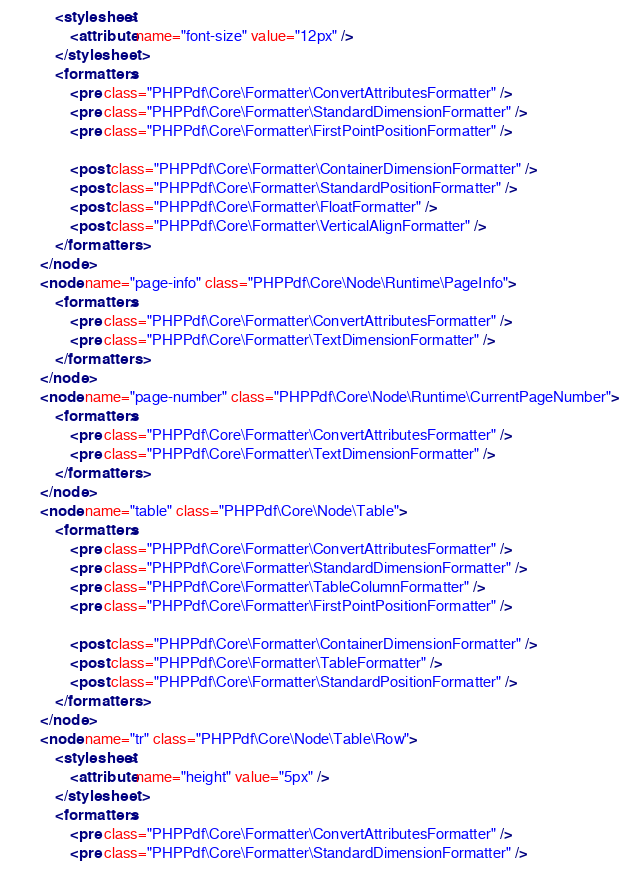Convert code to text. <code><loc_0><loc_0><loc_500><loc_500><_XML_>	        <stylesheet>
	            <attribute name="font-size" value="12px" />
	        </stylesheet>
	        <formatters>
	            <pre class="PHPPdf\Core\Formatter\ConvertAttributesFormatter" />
	            <pre class="PHPPdf\Core\Formatter\StandardDimensionFormatter" />
	            <pre class="PHPPdf\Core\Formatter\FirstPointPositionFormatter" />

	            <post class="PHPPdf\Core\Formatter\ContainerDimensionFormatter" />
	            <post class="PHPPdf\Core\Formatter\StandardPositionFormatter" />
	            <post class="PHPPdf\Core\Formatter\FloatFormatter" />
	            <post class="PHPPdf\Core\Formatter\VerticalAlignFormatter" />
	        </formatters>
	    </node>
	    <node name="page-info" class="PHPPdf\Core\Node\Runtime\PageInfo">
	        <formatters>
	            <pre class="PHPPdf\Core\Formatter\ConvertAttributesFormatter" />
	            <pre class="PHPPdf\Core\Formatter\TextDimensionFormatter" />
	        </formatters>
	    </node>
	    <node name="page-number" class="PHPPdf\Core\Node\Runtime\CurrentPageNumber">
	        <formatters>
	            <pre class="PHPPdf\Core\Formatter\ConvertAttributesFormatter" />
	            <pre class="PHPPdf\Core\Formatter\TextDimensionFormatter" />
	        </formatters>
	    </node>
	    <node name="table" class="PHPPdf\Core\Node\Table">
	        <formatters>
	            <pre class="PHPPdf\Core\Formatter\ConvertAttributesFormatter" />
	            <pre class="PHPPdf\Core\Formatter\StandardDimensionFormatter" />
	            <pre class="PHPPdf\Core\Formatter\TableColumnFormatter" />
	            <pre class="PHPPdf\Core\Formatter\FirstPointPositionFormatter" />

	            <post class="PHPPdf\Core\Formatter\ContainerDimensionFormatter" />
	            <post class="PHPPdf\Core\Formatter\TableFormatter" />
	            <post class="PHPPdf\Core\Formatter\StandardPositionFormatter" />
	        </formatters>
	    </node>
	    <node name="tr" class="PHPPdf\Core\Node\Table\Row">
	        <stylesheet>
	            <attribute name="height" value="5px" />
	        </stylesheet>
	        <formatters>
	            <pre class="PHPPdf\Core\Formatter\ConvertAttributesFormatter" />
	            <pre class="PHPPdf\Core\Formatter\StandardDimensionFormatter" /></code> 